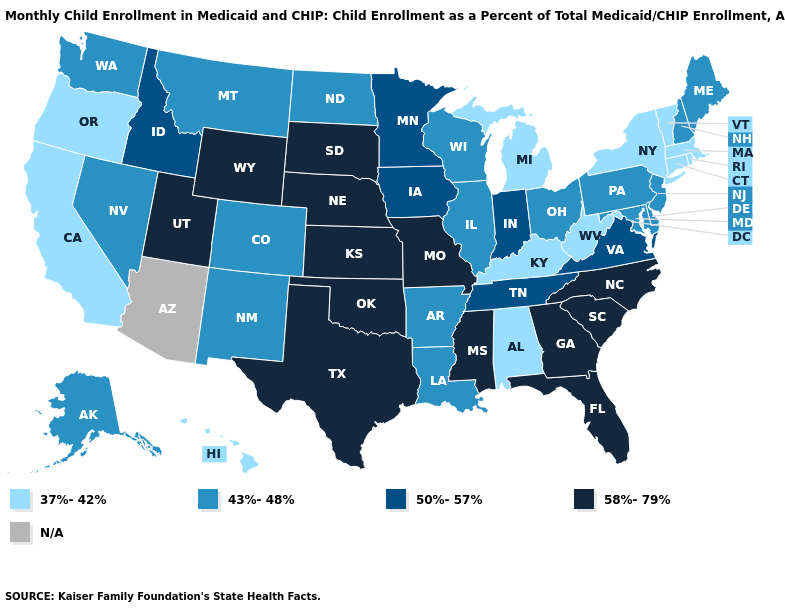What is the value of Michigan?
Short answer required. 37%-42%. Name the states that have a value in the range 37%-42%?
Write a very short answer. Alabama, California, Connecticut, Hawaii, Kentucky, Massachusetts, Michigan, New York, Oregon, Rhode Island, Vermont, West Virginia. Name the states that have a value in the range 50%-57%?
Quick response, please. Idaho, Indiana, Iowa, Minnesota, Tennessee, Virginia. What is the highest value in the South ?
Short answer required. 58%-79%. What is the value of Louisiana?
Short answer required. 43%-48%. What is the value of Colorado?
Write a very short answer. 43%-48%. What is the highest value in states that border Maine?
Short answer required. 43%-48%. What is the value of Ohio?
Write a very short answer. 43%-48%. Among the states that border Arizona , does Colorado have the highest value?
Write a very short answer. No. What is the value of Indiana?
Short answer required. 50%-57%. Among the states that border Nevada , does Idaho have the lowest value?
Quick response, please. No. What is the lowest value in the Northeast?
Answer briefly. 37%-42%. What is the value of Florida?
Short answer required. 58%-79%. What is the value of Iowa?
Answer briefly. 50%-57%. 